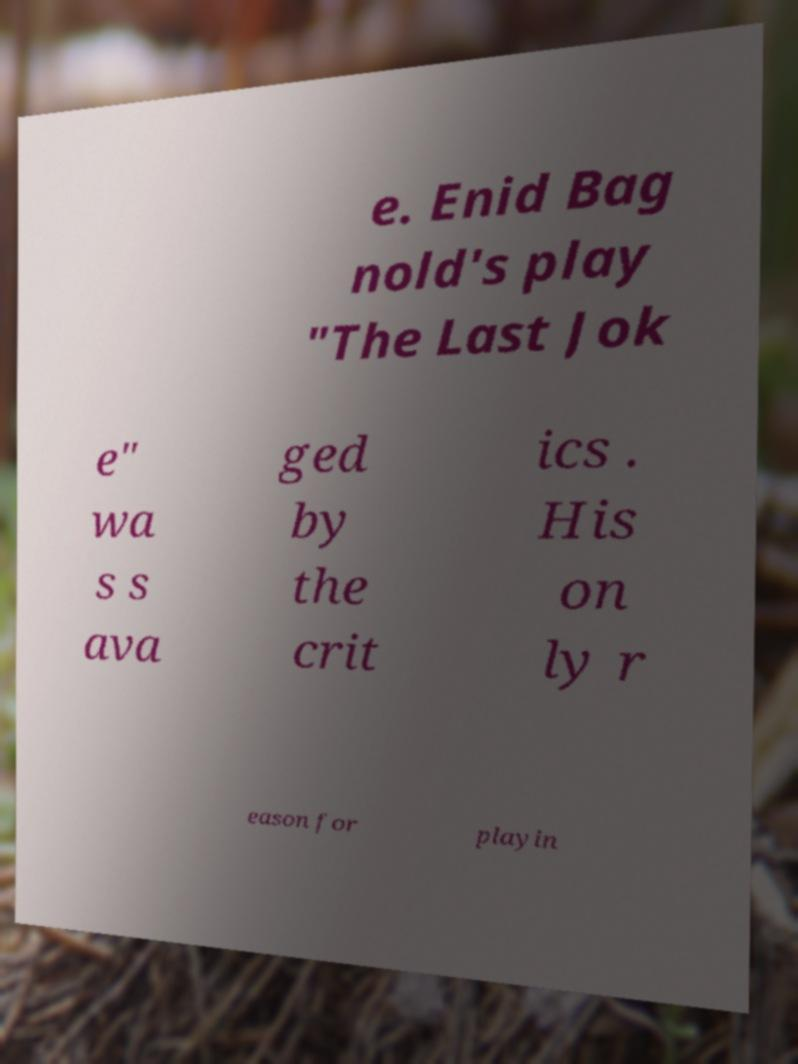There's text embedded in this image that I need extracted. Can you transcribe it verbatim? e. Enid Bag nold's play "The Last Jok e" wa s s ava ged by the crit ics . His on ly r eason for playin 